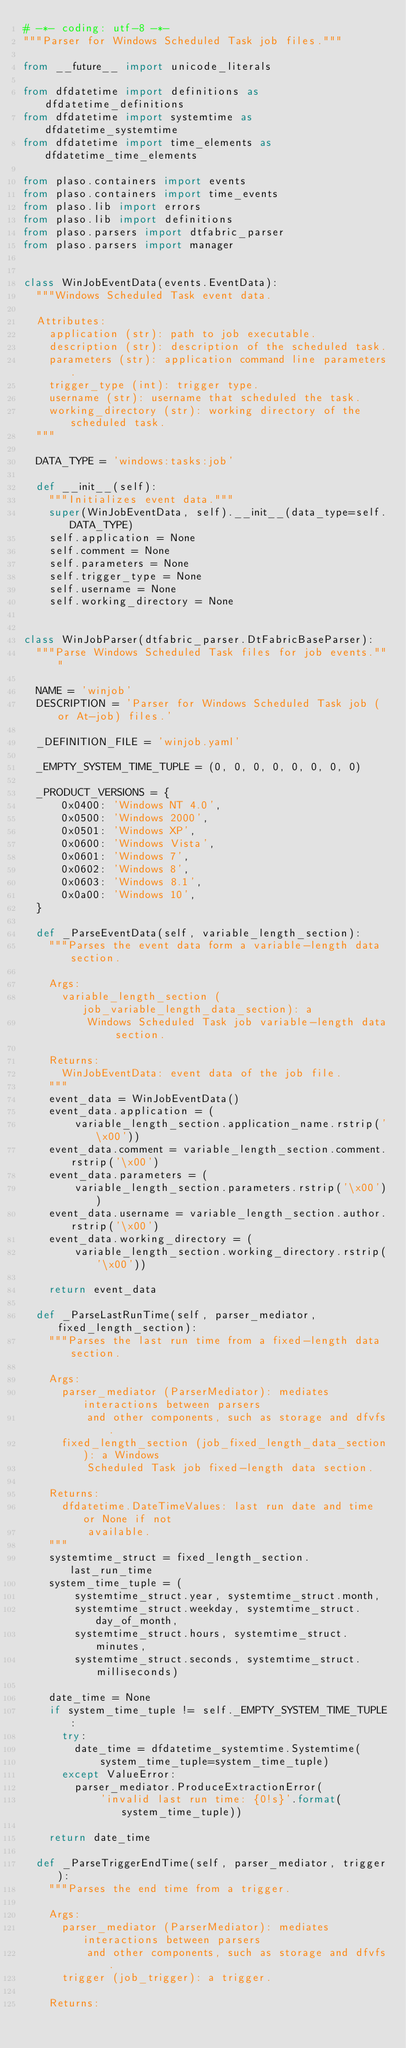Convert code to text. <code><loc_0><loc_0><loc_500><loc_500><_Python_># -*- coding: utf-8 -*-
"""Parser for Windows Scheduled Task job files."""

from __future__ import unicode_literals

from dfdatetime import definitions as dfdatetime_definitions
from dfdatetime import systemtime as dfdatetime_systemtime
from dfdatetime import time_elements as dfdatetime_time_elements

from plaso.containers import events
from plaso.containers import time_events
from plaso.lib import errors
from plaso.lib import definitions
from plaso.parsers import dtfabric_parser
from plaso.parsers import manager


class WinJobEventData(events.EventData):
  """Windows Scheduled Task event data.

  Attributes:
    application (str): path to job executable.
    description (str): description of the scheduled task.
    parameters (str): application command line parameters.
    trigger_type (int): trigger type.
    username (str): username that scheduled the task.
    working_directory (str): working directory of the scheduled task.
  """

  DATA_TYPE = 'windows:tasks:job'

  def __init__(self):
    """Initializes event data."""
    super(WinJobEventData, self).__init__(data_type=self.DATA_TYPE)
    self.application = None
    self.comment = None
    self.parameters = None
    self.trigger_type = None
    self.username = None
    self.working_directory = None


class WinJobParser(dtfabric_parser.DtFabricBaseParser):
  """Parse Windows Scheduled Task files for job events."""

  NAME = 'winjob'
  DESCRIPTION = 'Parser for Windows Scheduled Task job (or At-job) files.'

  _DEFINITION_FILE = 'winjob.yaml'

  _EMPTY_SYSTEM_TIME_TUPLE = (0, 0, 0, 0, 0, 0, 0, 0)

  _PRODUCT_VERSIONS = {
      0x0400: 'Windows NT 4.0',
      0x0500: 'Windows 2000',
      0x0501: 'Windows XP',
      0x0600: 'Windows Vista',
      0x0601: 'Windows 7',
      0x0602: 'Windows 8',
      0x0603: 'Windows 8.1',
      0x0a00: 'Windows 10',
  }

  def _ParseEventData(self, variable_length_section):
    """Parses the event data form a variable-length data section.

    Args:
      variable_length_section (job_variable_length_data_section): a
          Windows Scheduled Task job variable-length data section.

    Returns:
      WinJobEventData: event data of the job file.
    """
    event_data = WinJobEventData()
    event_data.application = (
        variable_length_section.application_name.rstrip('\x00'))
    event_data.comment = variable_length_section.comment.rstrip('\x00')
    event_data.parameters = (
        variable_length_section.parameters.rstrip('\x00'))
    event_data.username = variable_length_section.author.rstrip('\x00')
    event_data.working_directory = (
        variable_length_section.working_directory.rstrip('\x00'))

    return event_data

  def _ParseLastRunTime(self, parser_mediator, fixed_length_section):
    """Parses the last run time from a fixed-length data section.

    Args:
      parser_mediator (ParserMediator): mediates interactions between parsers
          and other components, such as storage and dfvfs.
      fixed_length_section (job_fixed_length_data_section): a Windows
          Scheduled Task job fixed-length data section.

    Returns:
      dfdatetime.DateTimeValues: last run date and time or None if not
          available.
    """
    systemtime_struct = fixed_length_section.last_run_time
    system_time_tuple = (
        systemtime_struct.year, systemtime_struct.month,
        systemtime_struct.weekday, systemtime_struct.day_of_month,
        systemtime_struct.hours, systemtime_struct.minutes,
        systemtime_struct.seconds, systemtime_struct.milliseconds)

    date_time = None
    if system_time_tuple != self._EMPTY_SYSTEM_TIME_TUPLE:
      try:
        date_time = dfdatetime_systemtime.Systemtime(
            system_time_tuple=system_time_tuple)
      except ValueError:
        parser_mediator.ProduceExtractionError(
            'invalid last run time: {0!s}'.format(system_time_tuple))

    return date_time

  def _ParseTriggerEndTime(self, parser_mediator, trigger):
    """Parses the end time from a trigger.

    Args:
      parser_mediator (ParserMediator): mediates interactions between parsers
          and other components, such as storage and dfvfs.
      trigger (job_trigger): a trigger.

    Returns:</code> 